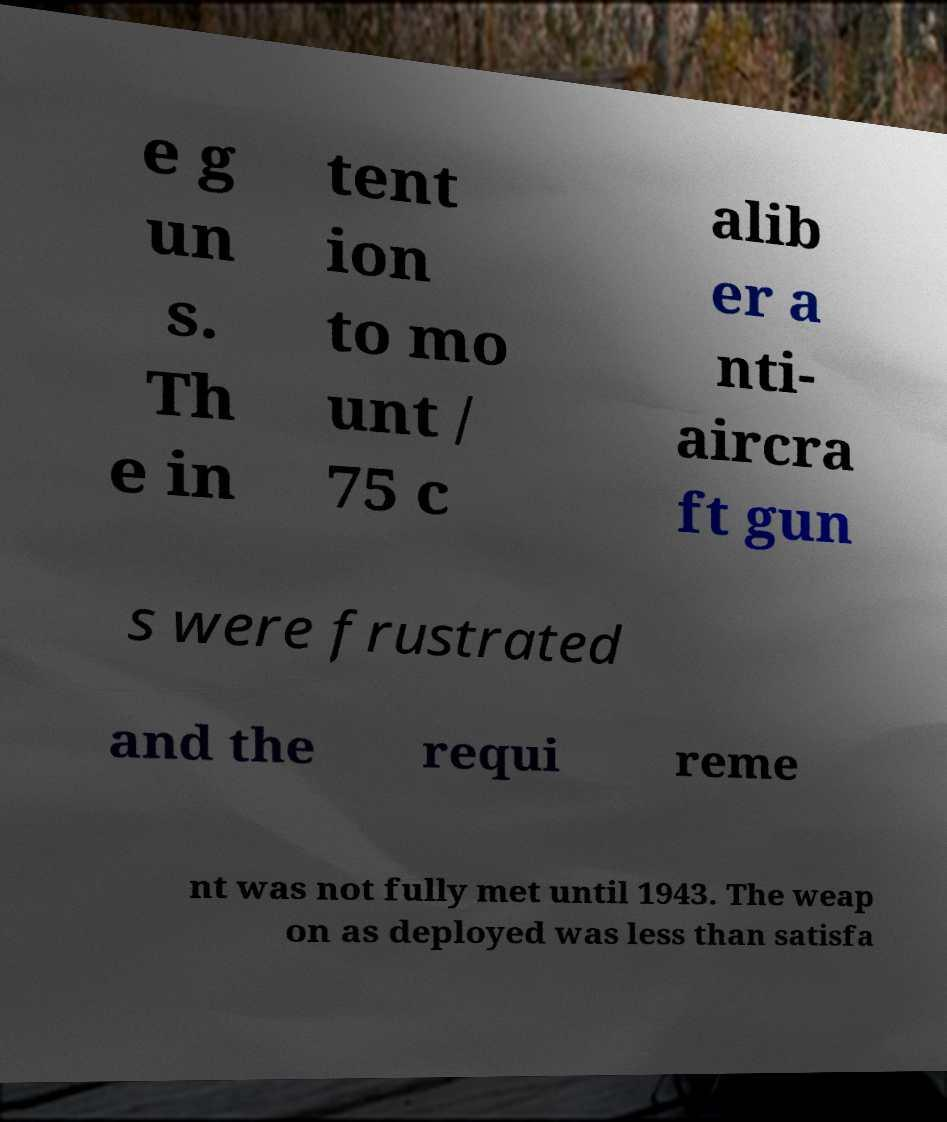I need the written content from this picture converted into text. Can you do that? e g un s. Th e in tent ion to mo unt / 75 c alib er a nti- aircra ft gun s were frustrated and the requi reme nt was not fully met until 1943. The weap on as deployed was less than satisfa 